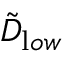<formula> <loc_0><loc_0><loc_500><loc_500>{ \tilde { D } } _ { l o w }</formula> 